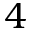<formula> <loc_0><loc_0><loc_500><loc_500>4</formula> 